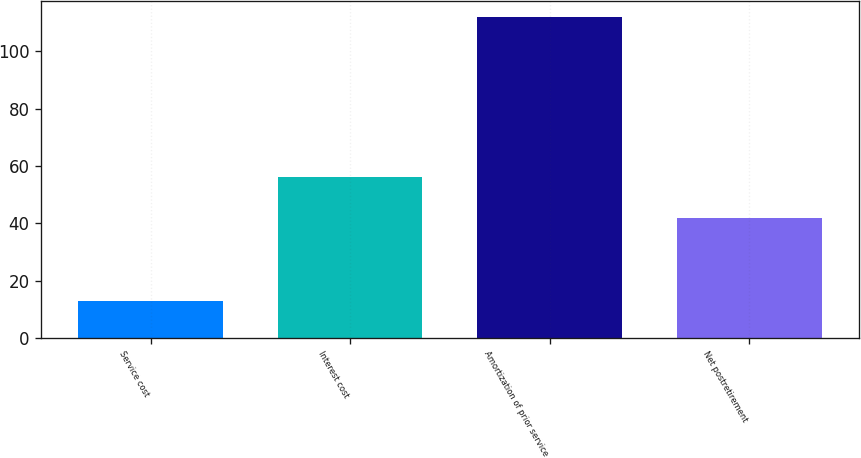<chart> <loc_0><loc_0><loc_500><loc_500><bar_chart><fcel>Service cost<fcel>Interest cost<fcel>Amortization of prior service<fcel>Net postretirement<nl><fcel>13<fcel>56<fcel>112<fcel>42<nl></chart> 